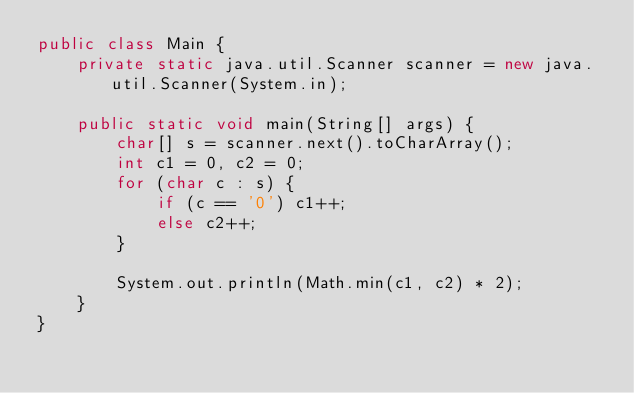<code> <loc_0><loc_0><loc_500><loc_500><_Java_>public class Main {
    private static java.util.Scanner scanner = new java.util.Scanner(System.in);

    public static void main(String[] args) {
        char[] s = scanner.next().toCharArray();
        int c1 = 0, c2 = 0;
        for (char c : s) {
            if (c == '0') c1++;
            else c2++;
        }

        System.out.println(Math.min(c1, c2) * 2);
    }
}</code> 